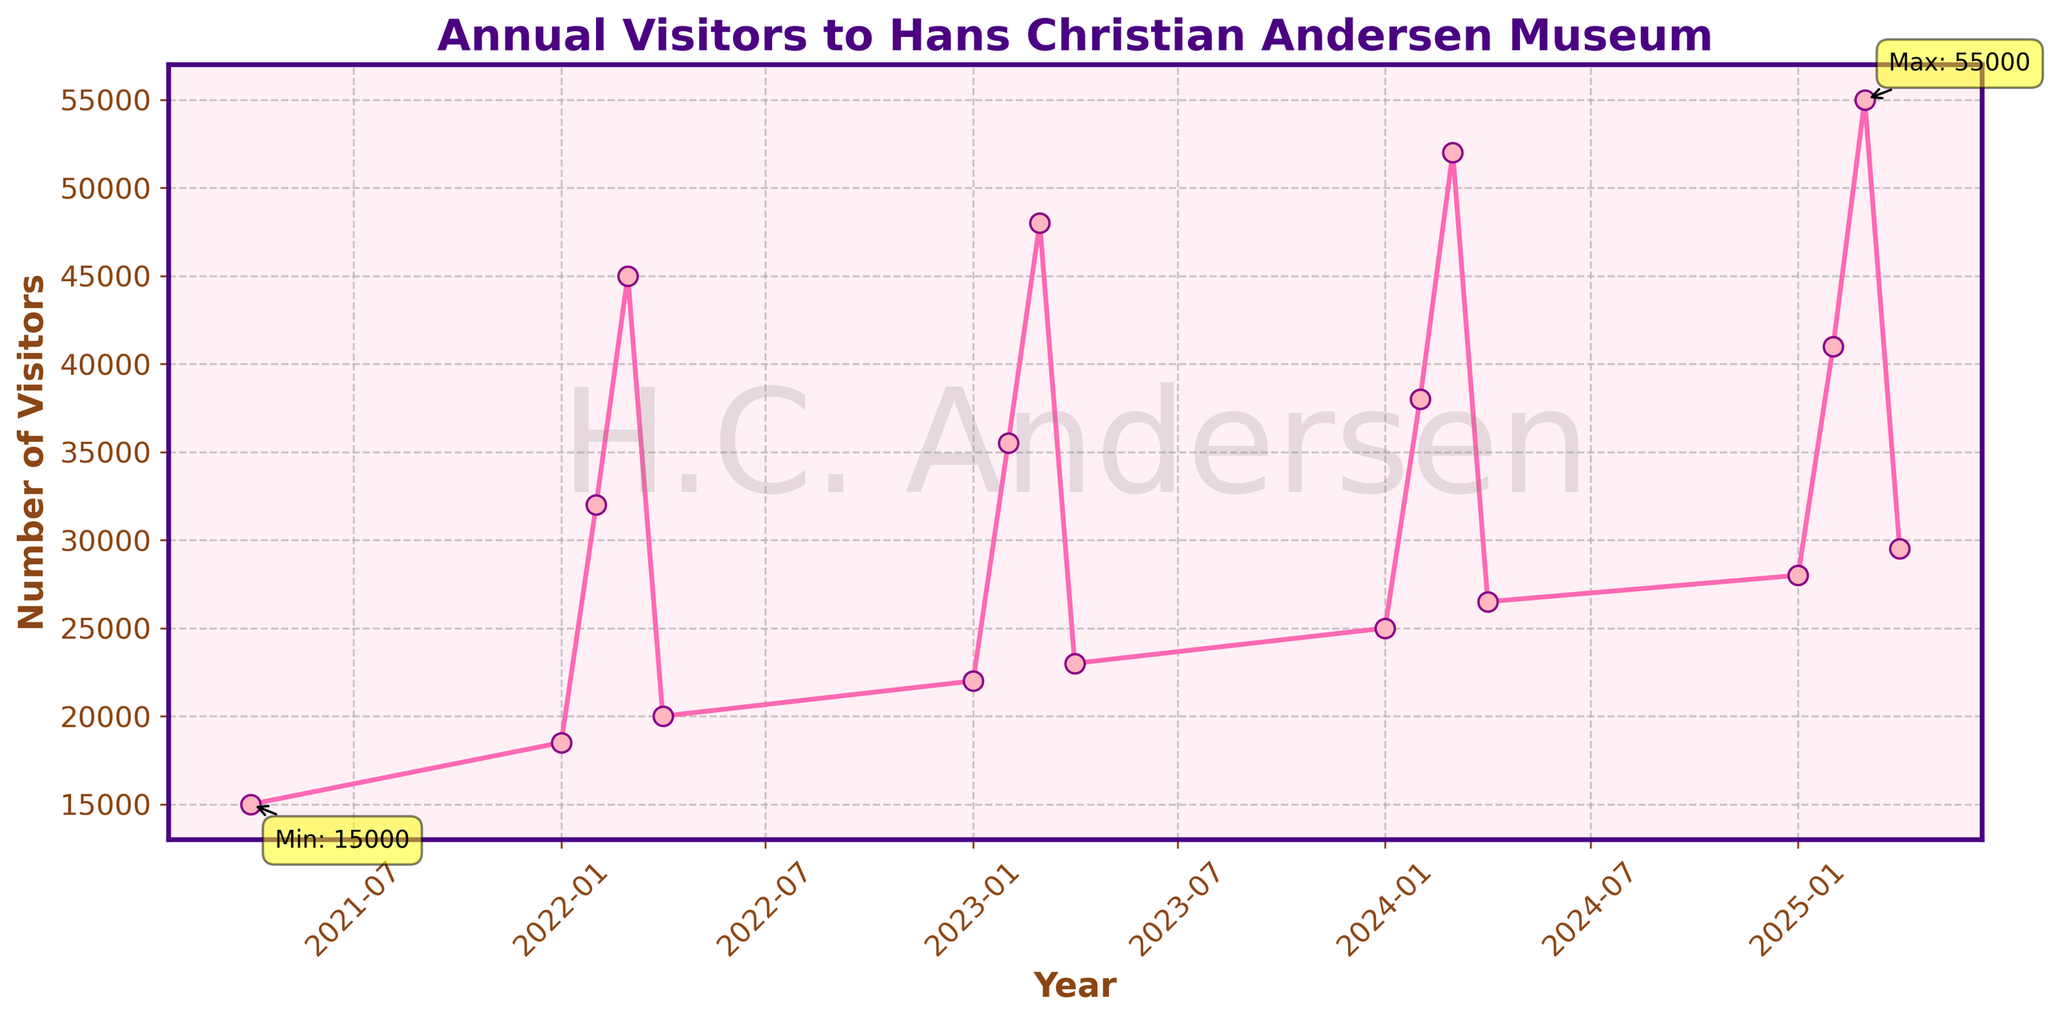How many visitors came to the Hans Christian Andersen Museum in the third quarter of 2023? The third quarter of 2023 shows 48,000 visitors on the plot.
Answer: 48,000 Which quarter between 2022 Q4 and 2023 Q1 had more visitors, and by how much? In 2022 Q4 there were 20,000 visitors, and in 2023 Q1 there were 22,000 visitors. The difference is 22,000 - 20,000 = 2,000 visitors.
Answer: 2023 Q1, 2,000 more visitors What is the range of the number of visitors over the entire period shown in the plot? The minimum number of visitors is 15,000 in 2021 Q4, and the maximum number of visitors is 55,000 in 2025 Q3. The range is 55,000 - 15,000 = 40,000 visitors.
Answer: 40,000 In which quarter did the number of visitors first exceed 40,000? By examining the plot, the first quarter where visitors exceeded 40,000 is the third quarter of 2022.
Answer: Q3 2022 How many more visitors were there in 2025 Q3 compared to 2024 Q3? In 2024 Q3 there were 52,000 visitors, and in 2025 Q3 there were 55,000 visitors. The difference is 55,000 - 52,000 = 3,000 visitors.
Answer: 3,000 Is the trend of visitors between Q3 and Q4 consistent every year? Observing the plot, the number of visitors consistently drops from Q3 to Q4 each year.
Answer: Yes In which year did the museum see the lowest number of visitors in the first quarter? By looking at the plot, the lowest number of visitors in the first quarter was in 2022 Q1 with 18,500 visitors.
Answer: 2022 What is the average number of visitors per quarter in 2024? The visitors in each quarter of 2024 are 25,000, 38,000, 52,000, and 26,500. The average is (25,000 + 38,000 + 52,000 + 26,500) / 4 = 35,375 visitors per quarter.
Answer: 35,375 Compare the number of visitors in Q1 and Q2 of 2025. Which quarter had more visitors and by how much? In 2025 Q1 there were 28,000 visitors, and in 2025 Q2 there were 41,000 visitors. The difference is 41,000 - 28,000 = 13,000 visitors.
Answer: Q2 2025, 13,000 more visitors In which quarter and year was the peak number of visitors achieved? The highest point on the plot is for Q3 2025 with 55,000 visitors.
Answer: Q3 2025 